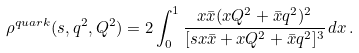<formula> <loc_0><loc_0><loc_500><loc_500>\rho ^ { q u a r k } ( s , q ^ { 2 } , Q ^ { 2 } ) = 2 \int _ { 0 } ^ { 1 } \frac { x \bar { x } ( x Q ^ { 2 } + \bar { x } q ^ { 2 } ) ^ { 2 } } { [ s { x } \bar { x } + x Q ^ { 2 } + \bar { x } q ^ { 2 } ] ^ { 3 } } \, d x \, .</formula> 